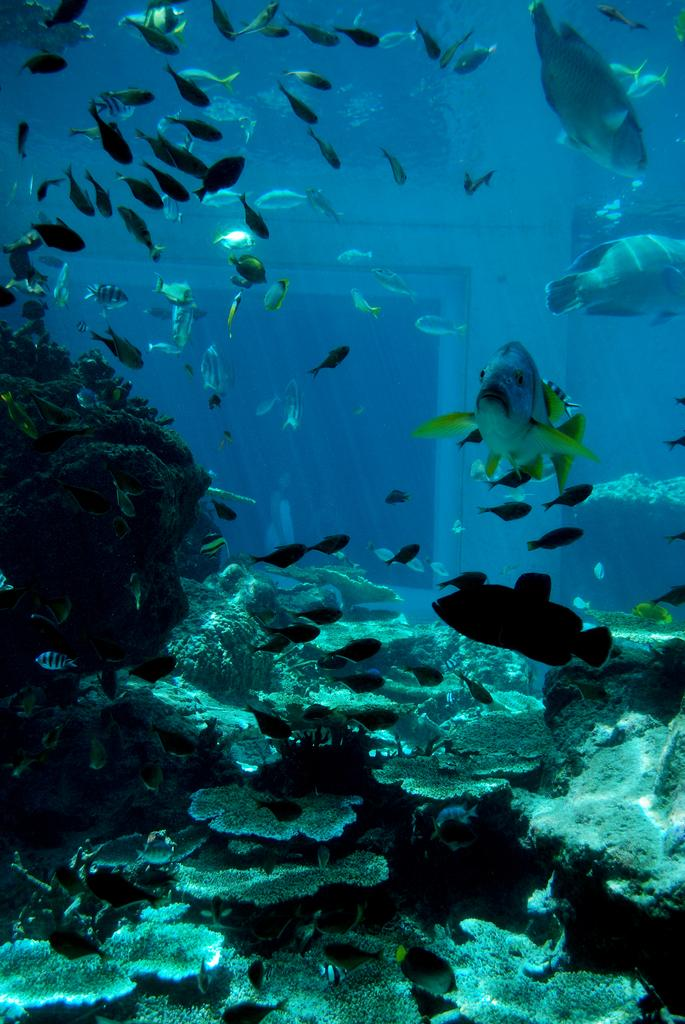What type of animals can be seen in the image? There are fishes in the image. Where are the fishes located? The fishes are in an aquarium. What type of cattle can be seen grazing in the image? There is no cattle present in the image; it features fishes in an aquarium. What type of bag is being used to carry the thread in the image? There is no bag or thread present in the image. 